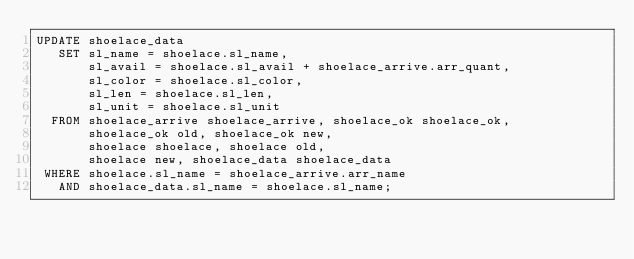<code> <loc_0><loc_0><loc_500><loc_500><_SQL_>UPDATE shoelace_data
   SET sl_name = shoelace.sl_name,
       sl_avail = shoelace.sl_avail + shoelace_arrive.arr_quant,
       sl_color = shoelace.sl_color,
       sl_len = shoelace.sl_len,
       sl_unit = shoelace.sl_unit
  FROM shoelace_arrive shoelace_arrive, shoelace_ok shoelace_ok,
       shoelace_ok old, shoelace_ok new,
       shoelace shoelace, shoelace old,
       shoelace new, shoelace_data shoelace_data
 WHERE shoelace.sl_name = shoelace_arrive.arr_name
   AND shoelace_data.sl_name = shoelace.sl_name;
</code> 